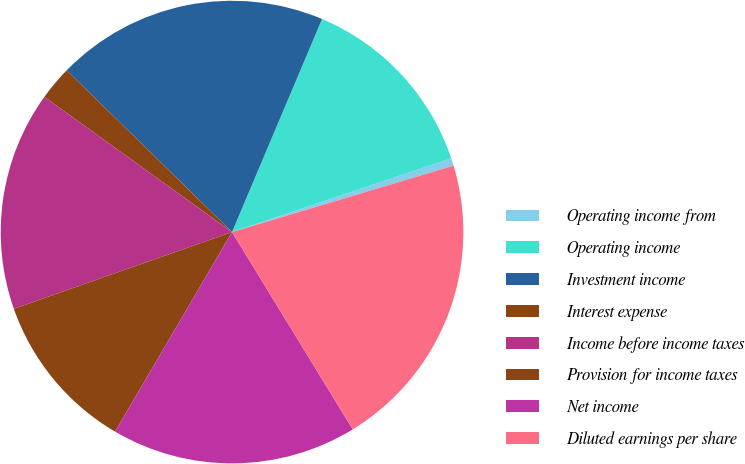<chart> <loc_0><loc_0><loc_500><loc_500><pie_chart><fcel>Operating income from<fcel>Operating income<fcel>Investment income<fcel>Interest expense<fcel>Income before income taxes<fcel>Provision for income taxes<fcel>Net income<fcel>Diluted earnings per share<nl><fcel>0.53%<fcel>13.47%<fcel>19.04%<fcel>2.39%<fcel>15.32%<fcel>11.18%<fcel>17.18%<fcel>20.9%<nl></chart> 